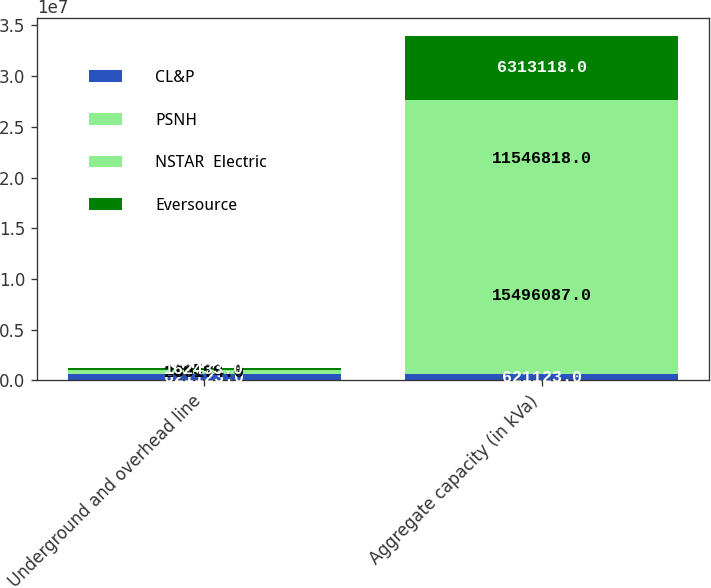Convert chart. <chart><loc_0><loc_0><loc_500><loc_500><stacked_bar_chart><ecel><fcel>Underground and overhead line<fcel>Aggregate capacity (in kVa)<nl><fcel>CL&P<fcel>621123<fcel>621123<nl><fcel>PSNH<fcel>289174<fcel>1.54961e+07<nl><fcel>NSTAR  Electric<fcel>126566<fcel>1.15468e+07<nl><fcel>Eversource<fcel>162433<fcel>6.31312e+06<nl></chart> 